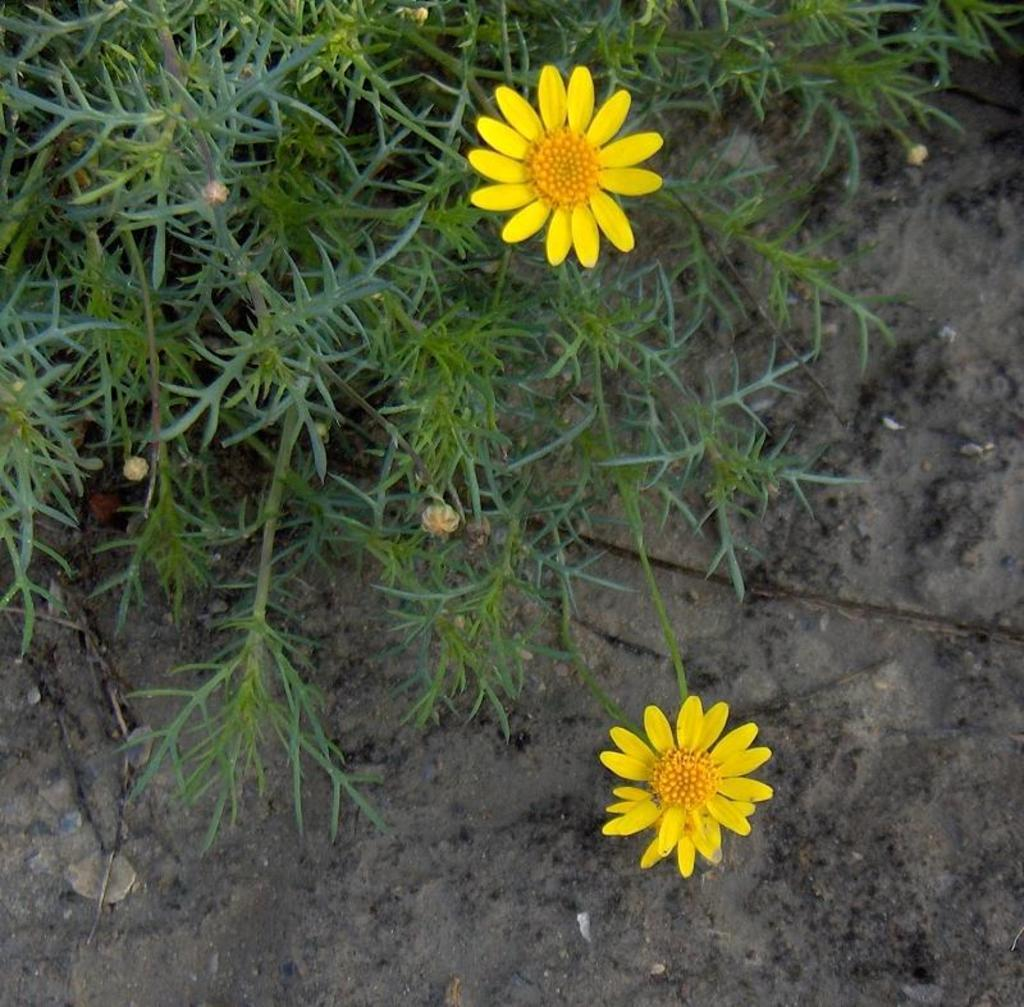What type of living organisms can be seen in the image? There are flowers on plants in the image. What can be seen beneath the plants in the image? The ground is visible in the image. What type of haircut does the beetle have in the image? There is no beetle present in the image, so it is not possible to determine its haircut. 